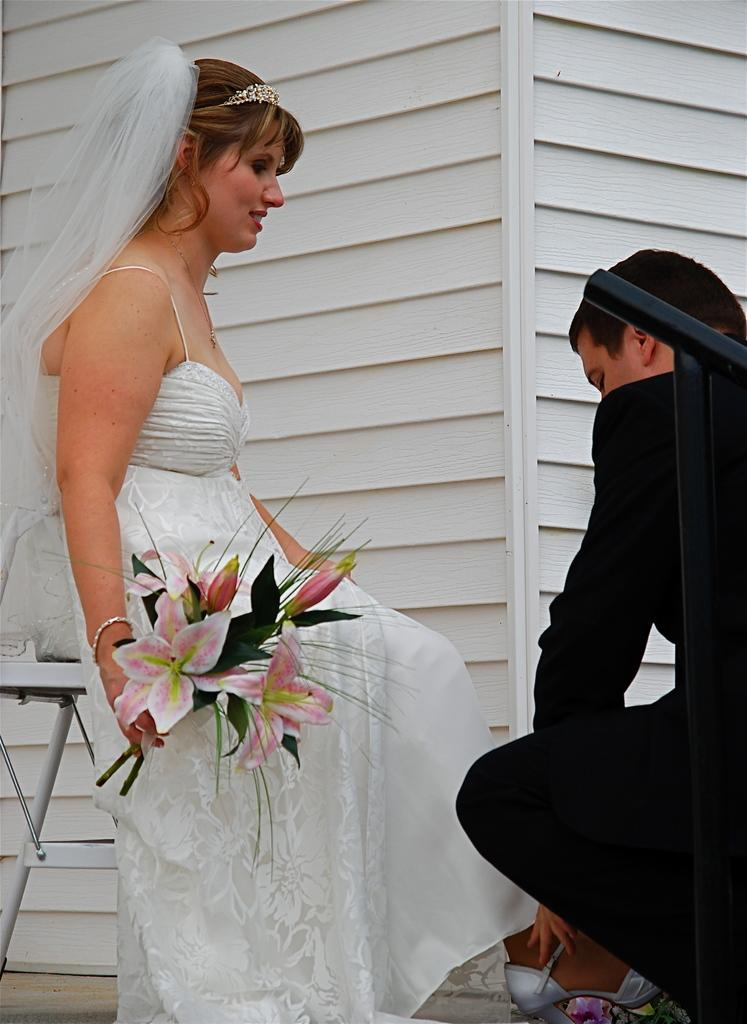Who are the two people in the image? There is a couple in the image. What is the woman holding in the image? The woman is holding a bouquet. What can be seen in the background of the image? There is a wall in the background of the image. What type of fan is visible in the image? There is no fan present in the image. Is the couple in the image spying on someone? There is no indication in the image that the couple is spying on anyone. 